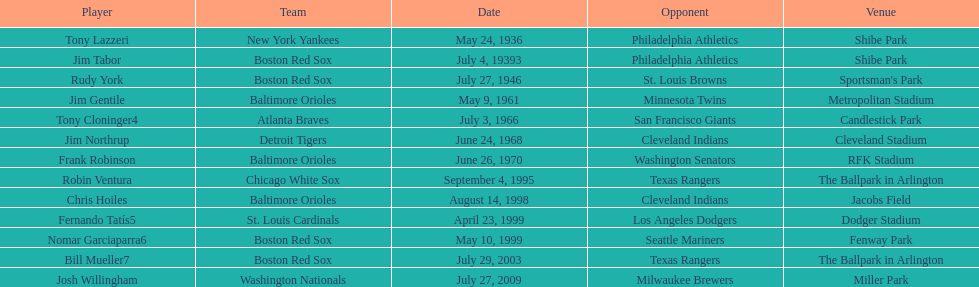Which major league batter was the first to hit two grand slams during a single game? Tony Lazzeri. 